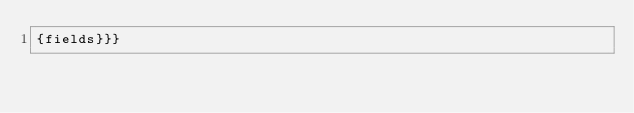<code> <loc_0><loc_0><loc_500><loc_500><_Rust_>{fields}}}</code> 